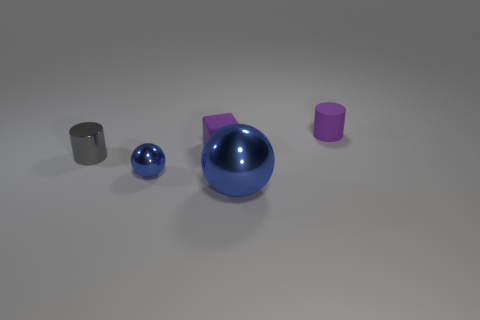Do the cylinder that is to the left of the tiny purple cylinder and the rubber thing that is right of the tiny matte block have the same color?
Your response must be concise. No. What number of rubber objects are either cyan objects or large balls?
Your answer should be compact. 0. There is a small purple rubber thing that is to the left of the tiny cylinder that is right of the gray object; how many tiny blue balls are left of it?
Your response must be concise. 1. There is a cylinder that is the same material as the big blue object; what is its size?
Make the answer very short. Small. What number of small objects are the same color as the shiny cylinder?
Your response must be concise. 0. There is a cylinder that is right of the shiny cylinder; is its size the same as the small blue thing?
Your answer should be very brief. Yes. What is the color of the thing that is in front of the small block and right of the purple block?
Your answer should be very brief. Blue. How many objects are either tiny matte blocks or things in front of the tiny blue ball?
Provide a short and direct response. 2. What material is the cylinder that is behind the small purple matte thing that is in front of the cylinder that is on the right side of the small gray object?
Ensure brevity in your answer.  Rubber. Is there anything else that is the same material as the tiny block?
Provide a succinct answer. Yes. 